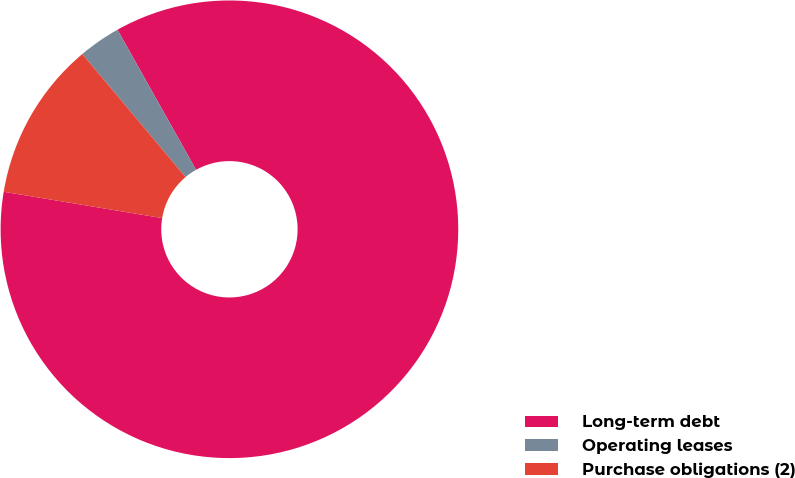Convert chart. <chart><loc_0><loc_0><loc_500><loc_500><pie_chart><fcel>Long-term debt<fcel>Operating leases<fcel>Purchase obligations (2)<nl><fcel>85.76%<fcel>2.98%<fcel>11.26%<nl></chart> 